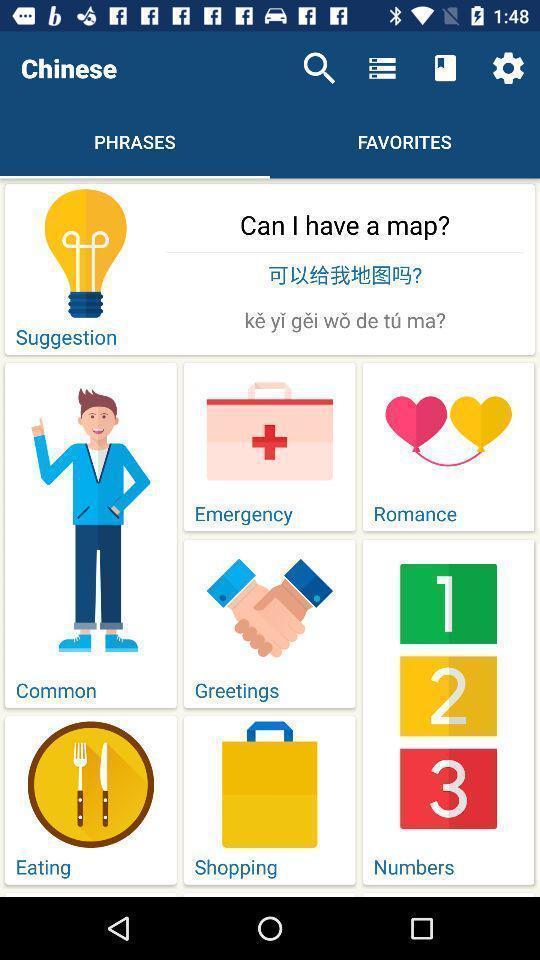Give me a narrative description of this picture. Page that displaying phrases menu. 